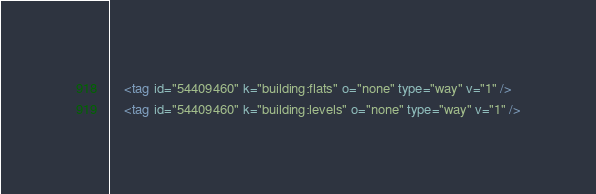<code> <loc_0><loc_0><loc_500><loc_500><_XML_>    <tag id="54409460" k="building:flats" o="none" type="way" v="1" />
    <tag id="54409460" k="building:levels" o="none" type="way" v="1" /></code> 